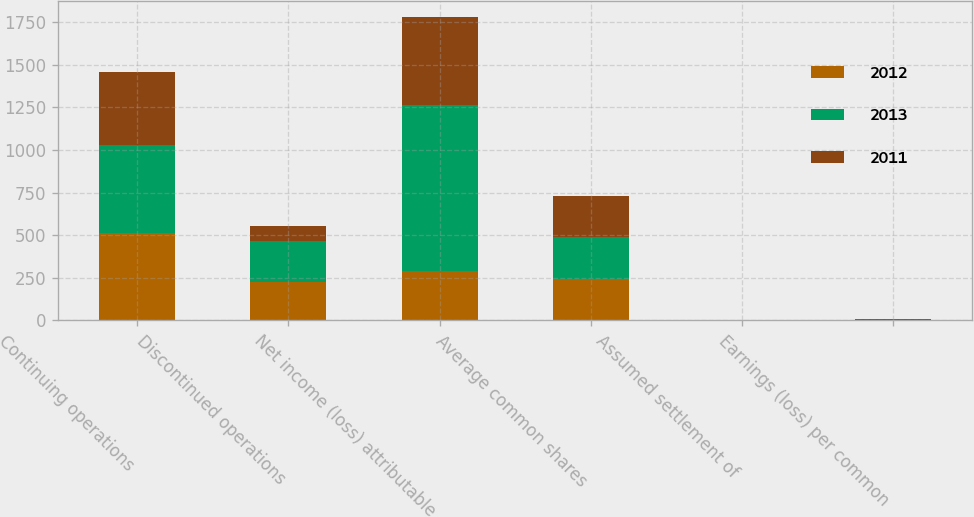Convert chart. <chart><loc_0><loc_0><loc_500><loc_500><stacked_bar_chart><ecel><fcel>Continuing operations<fcel>Discontinued operations<fcel>Net income (loss) attributable<fcel>Average common shares<fcel>Assumed settlement of<fcel>Earnings (loss) per common<nl><fcel>2012<fcel>512<fcel>223<fcel>289<fcel>244.5<fcel>1.9<fcel>1.18<nl><fcel>2013<fcel>516<fcel>241.5<fcel>974<fcel>243<fcel>0.4<fcel>4.01<nl><fcel>2011<fcel>431<fcel>88<fcel>519<fcel>242.1<fcel>0.6<fcel>2.15<nl></chart> 